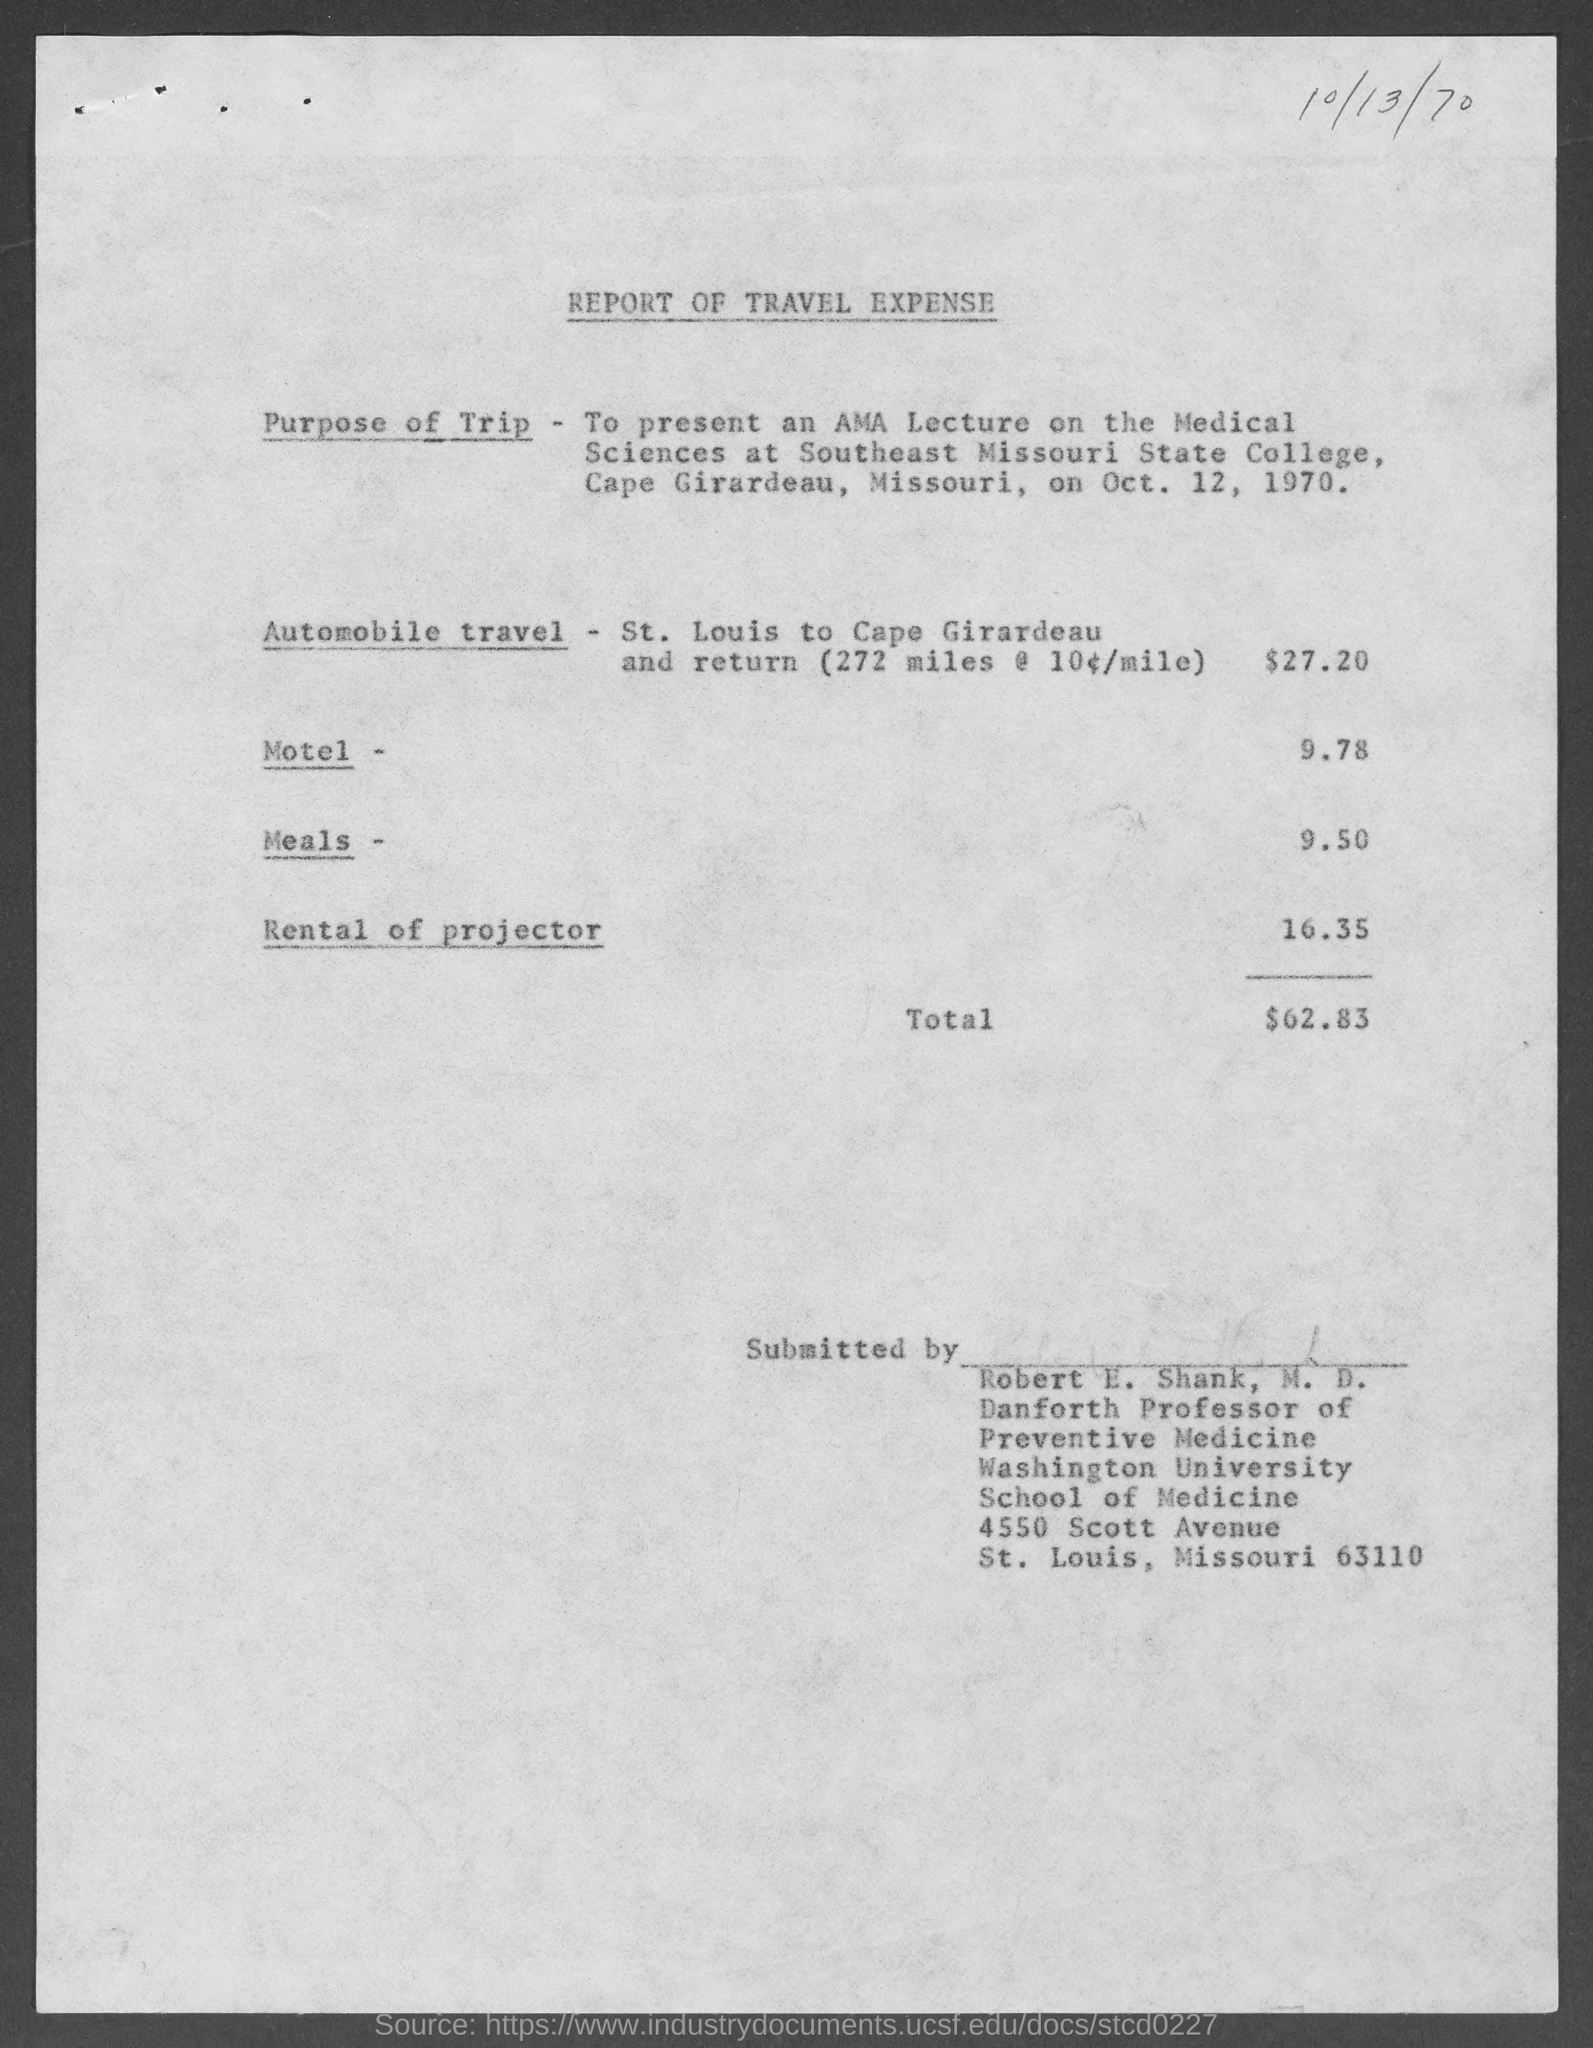Point out several critical features in this image. The expense for renting a projector was 16.35. The expense on meals is $9.50. The total amount of expense is 62.83. The street address of Washington University School of Medicine is 4550 Scott Avenue. The expense on the motel was $9.78. 